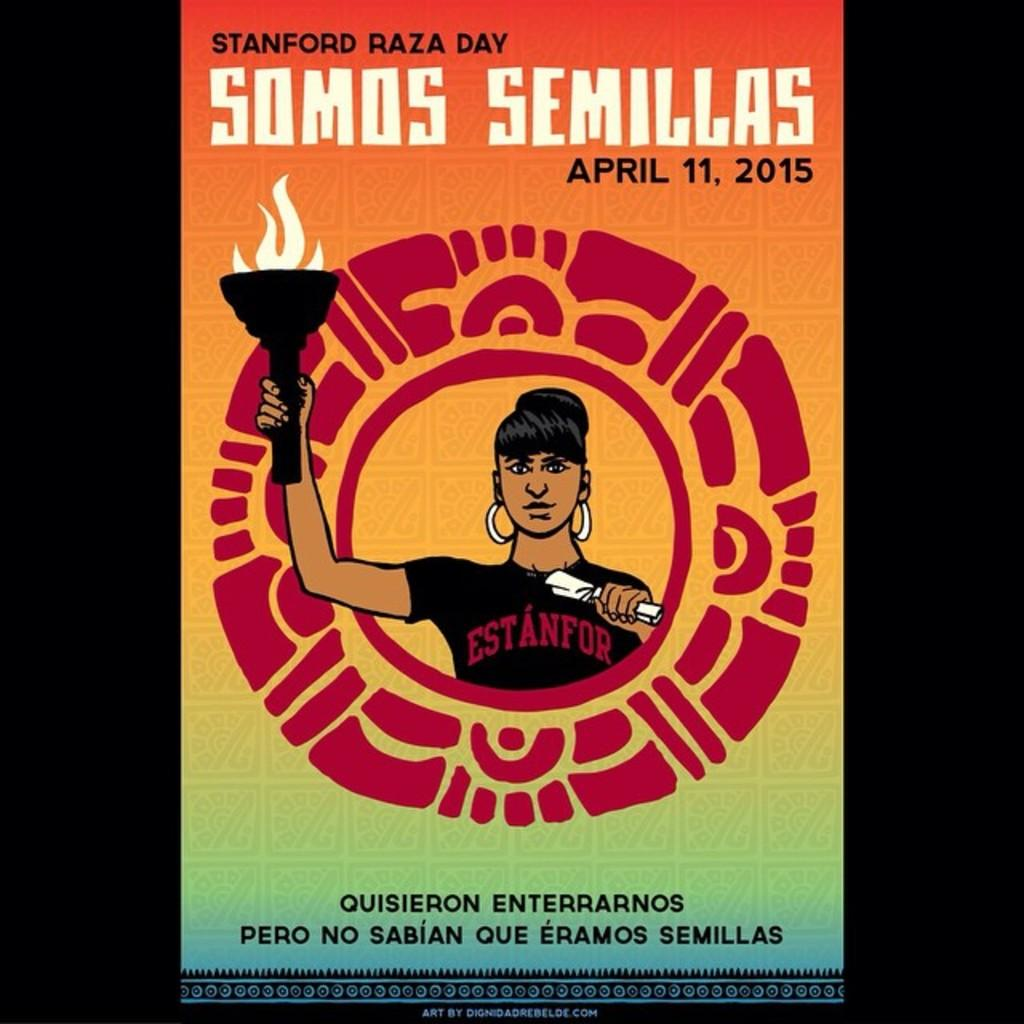Provide a one-sentence caption for the provided image. Standford Raza Day took place on April 11, 2015. 